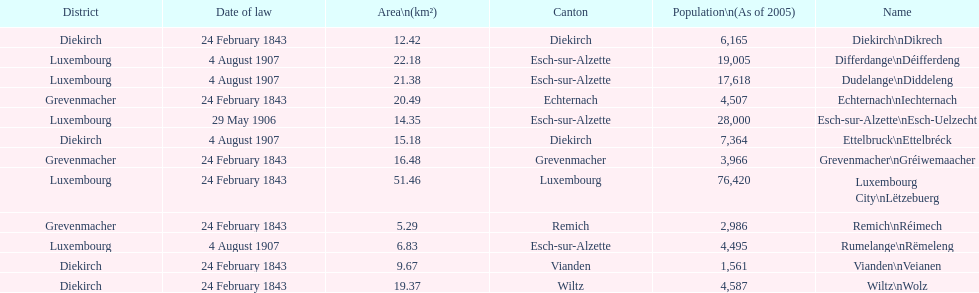Could you parse the entire table? {'header': ['District', 'Date of law', 'Area\\n(km²)', 'Canton', 'Population\\n(As of 2005)', 'Name'], 'rows': [['Diekirch', '24 February 1843', '12.42', 'Diekirch', '6,165', 'Diekirch\\nDikrech'], ['Luxembourg', '4 August 1907', '22.18', 'Esch-sur-Alzette', '19,005', 'Differdange\\nDéifferdeng'], ['Luxembourg', '4 August 1907', '21.38', 'Esch-sur-Alzette', '17,618', 'Dudelange\\nDiddeleng'], ['Grevenmacher', '24 February 1843', '20.49', 'Echternach', '4,507', 'Echternach\\nIechternach'], ['Luxembourg', '29 May 1906', '14.35', 'Esch-sur-Alzette', '28,000', 'Esch-sur-Alzette\\nEsch-Uelzecht'], ['Diekirch', '4 August 1907', '15.18', 'Diekirch', '7,364', 'Ettelbruck\\nEttelbréck'], ['Grevenmacher', '24 February 1843', '16.48', 'Grevenmacher', '3,966', 'Grevenmacher\\nGréiwemaacher'], ['Luxembourg', '24 February 1843', '51.46', 'Luxembourg', '76,420', 'Luxembourg City\\nLëtzebuerg'], ['Grevenmacher', '24 February 1843', '5.29', 'Remich', '2,986', 'Remich\\nRéimech'], ['Luxembourg', '4 August 1907', '6.83', 'Esch-sur-Alzette', '4,495', 'Rumelange\\nRëmeleng'], ['Diekirch', '24 February 1843', '9.67', 'Vianden', '1,561', 'Vianden\\nVeianen'], ['Diekirch', '24 February 1843', '19.37', 'Wiltz', '4,587', 'Wiltz\\nWolz']]} What canton is the most populated? Luxembourg. 